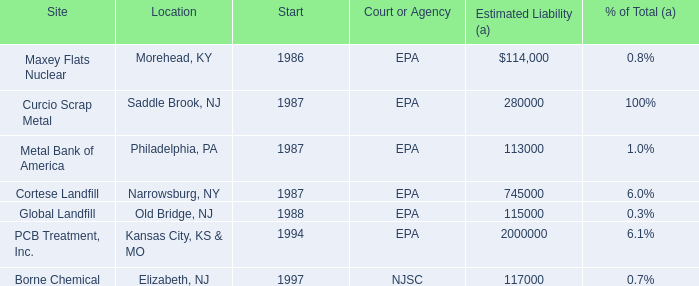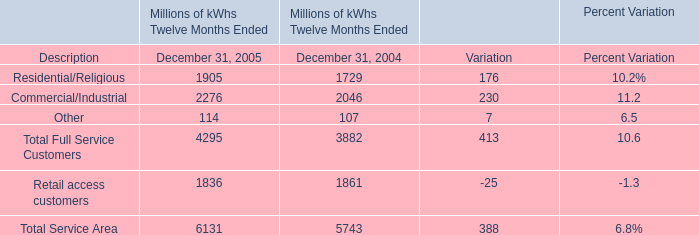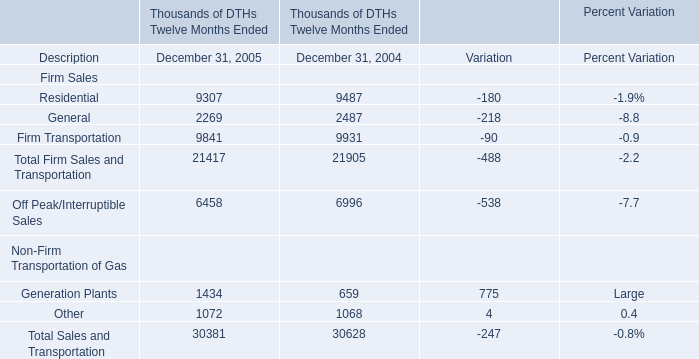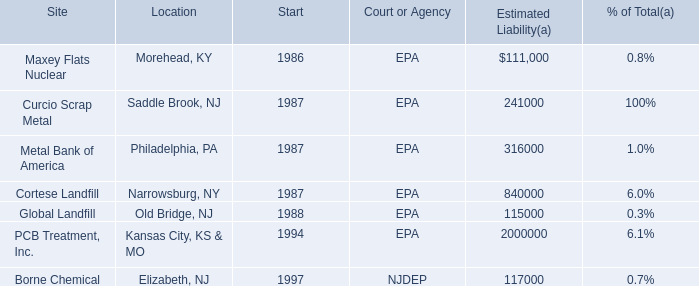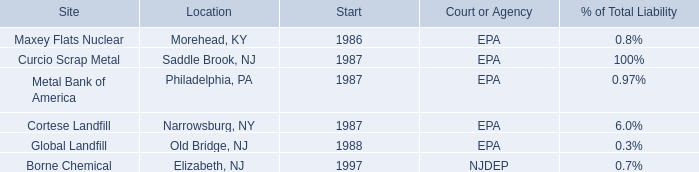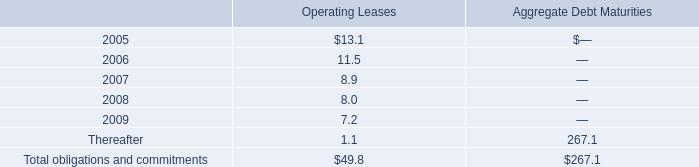What is the sum of Total Sales and Transportation in 2005? (in thousand) 
Computations: (((21417 + 6458) + 1434) + 1072)
Answer: 30381.0. 